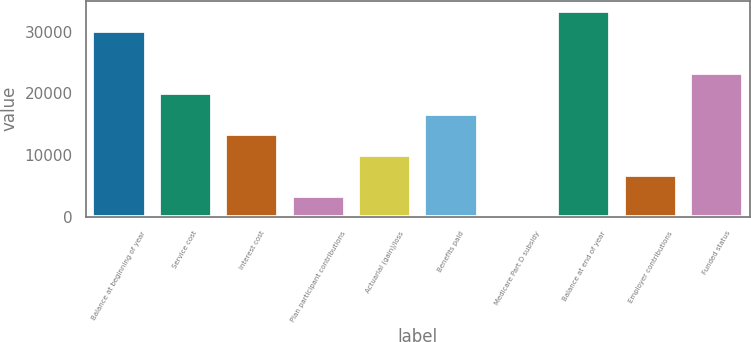Convert chart. <chart><loc_0><loc_0><loc_500><loc_500><bar_chart><fcel>Balance at beginning of year<fcel>Service cost<fcel>Interest cost<fcel>Plan participant contributions<fcel>Actuarial (gain)/loss<fcel>Benefits paid<fcel>Medicare Part D subsidy<fcel>Balance at end of year<fcel>Employer contributions<fcel>Funded status<nl><fcel>30048.8<fcel>20061.2<fcel>13402.8<fcel>3415.2<fcel>10073.6<fcel>16732<fcel>86<fcel>33378<fcel>6744.4<fcel>23390.4<nl></chart> 